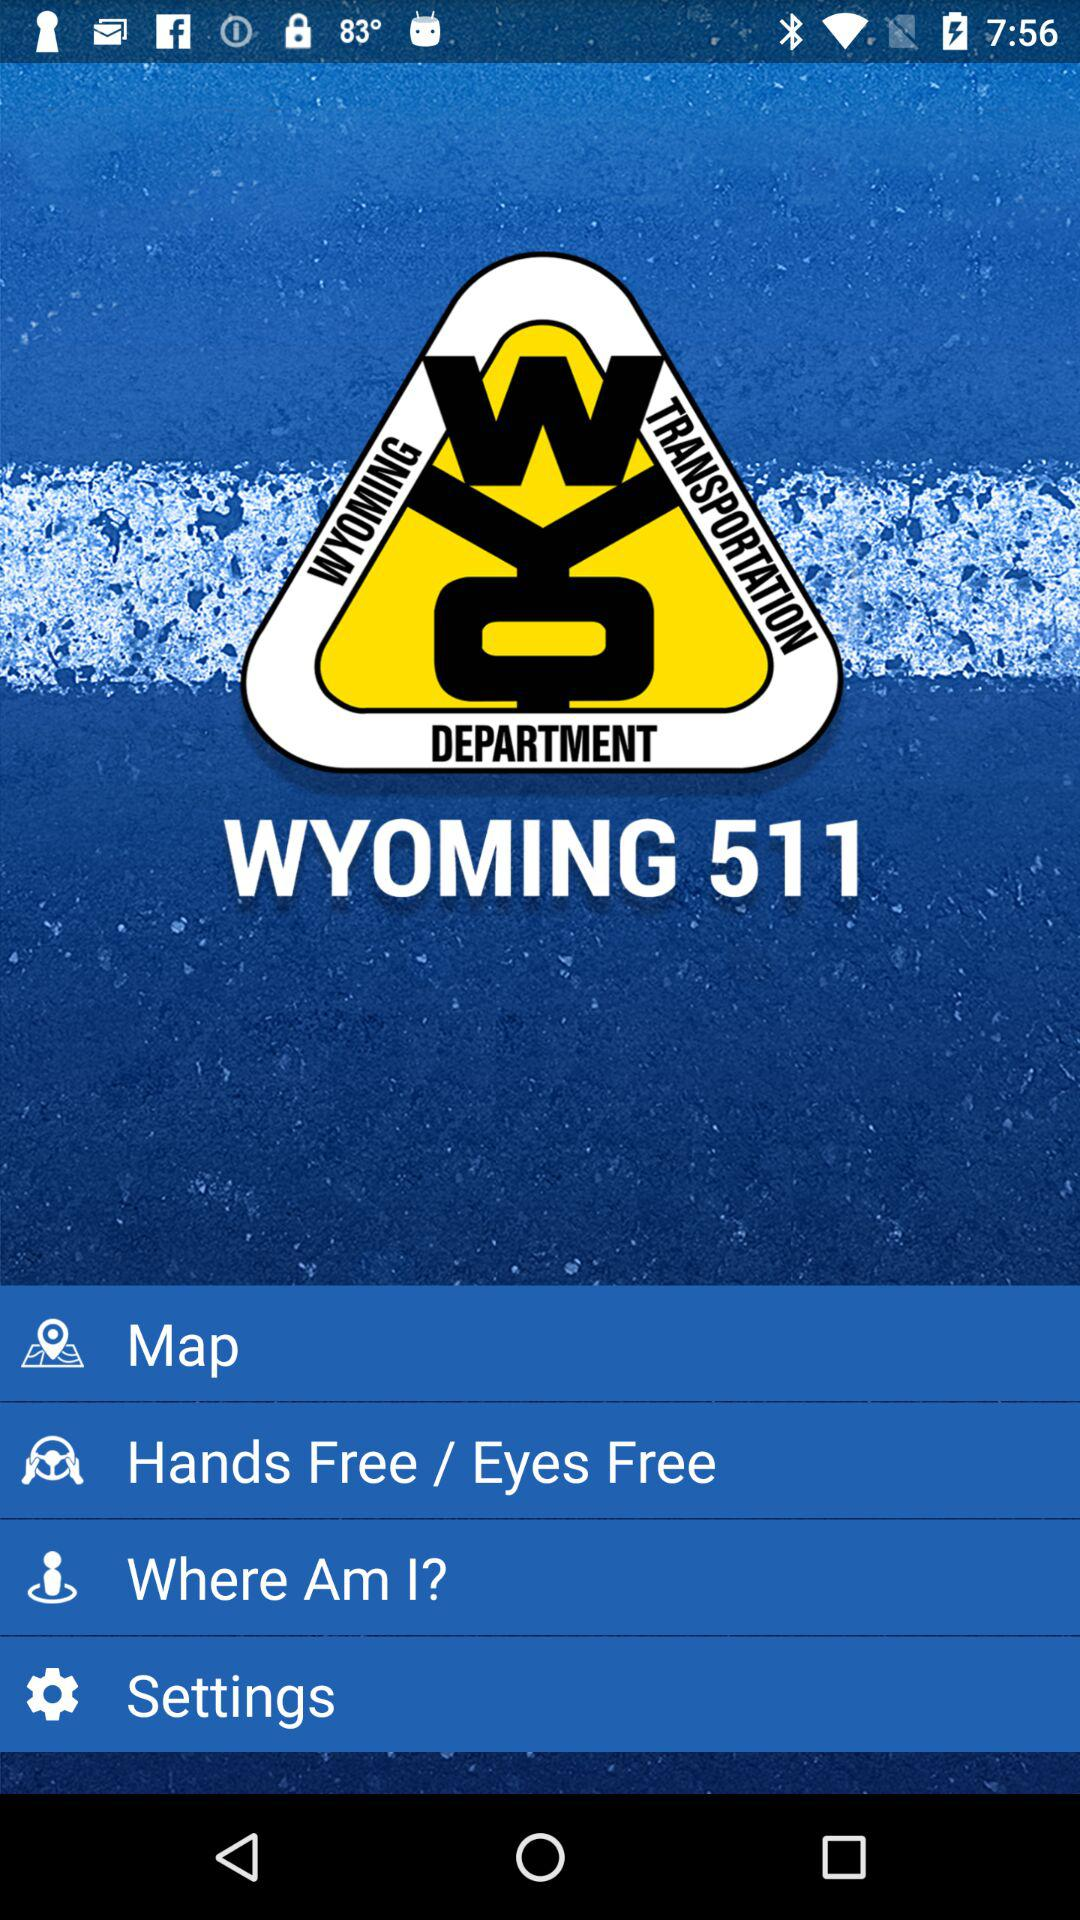What is the name of the application? The application name is "WYOMING 511". 